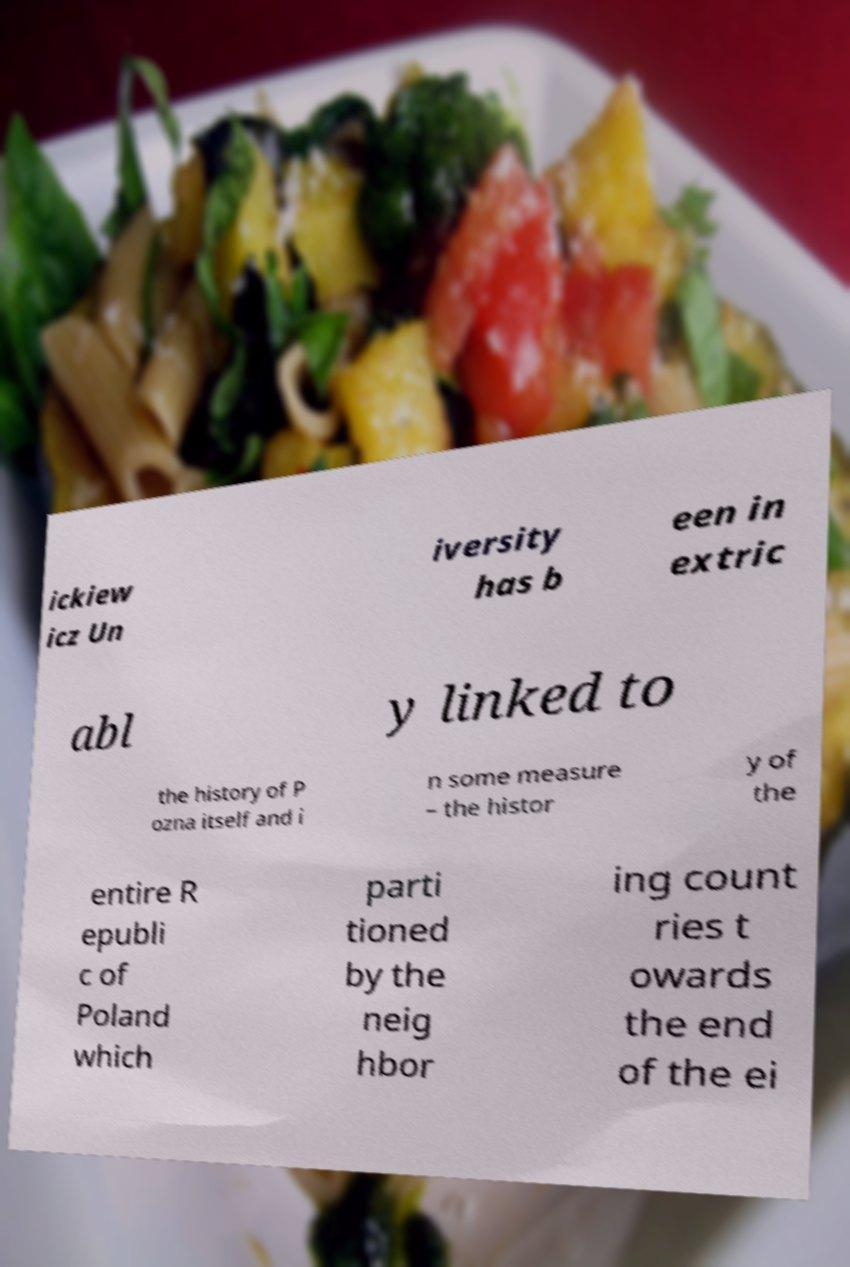I need the written content from this picture converted into text. Can you do that? ickiew icz Un iversity has b een in extric abl y linked to the history of P ozna itself and i n some measure – the histor y of the entire R epubli c of Poland which parti tioned by the neig hbor ing count ries t owards the end of the ei 